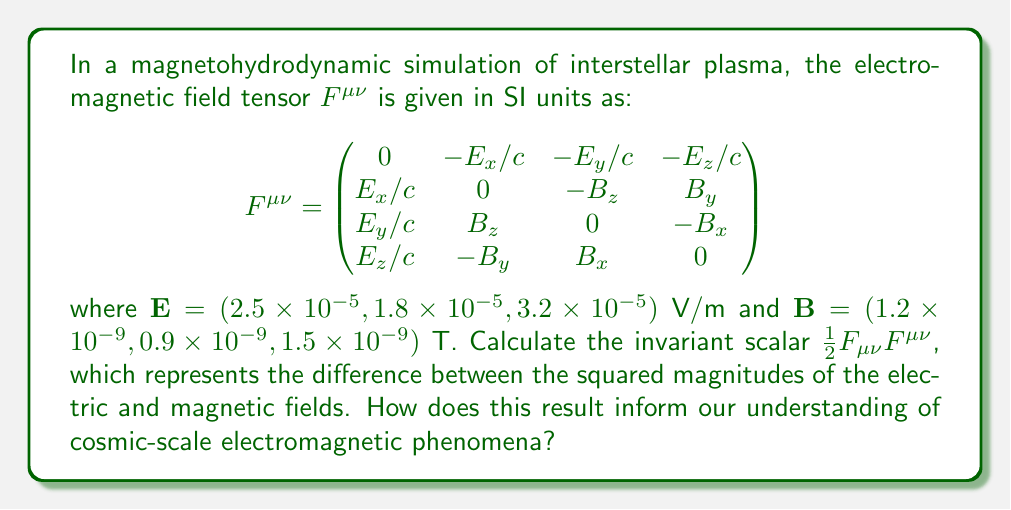Teach me how to tackle this problem. To solve this problem, we'll follow these steps:

1) First, we need to calculate $F_{\mu\nu}$. This is the covariant form of the tensor, obtained by lowering the indices of $F^{\mu\nu}$ using the Minkowski metric $\eta_{\mu\nu} = \text{diag}(-1, 1, 1, 1)$:

   $$F_{\mu\nu} = \begin{pmatrix}
   0 & E_x/c & E_y/c & E_z/c \\
   -E_x/c & 0 & -B_z & B_y \\
   -E_y/c & B_z & 0 & -B_x \\
   -E_z/c & -B_y & B_x & 0
   \end{pmatrix}$$

2) Now, we can calculate $\frac{1}{2}F_{\mu\nu}F^{\mu\nu}$. This contraction gives:

   $$\frac{1}{2}F_{\mu\nu}F^{\mu\nu} = \frac{1}{2}(-\frac{E_x^2}{c^2} - \frac{E_y^2}{c^2} - \frac{E_z^2}{c^2} + B_x^2 + B_y^2 + B_z^2 - \frac{E_x^2}{c^2} - \frac{E_y^2}{c^2} - \frac{E_z^2}{c^2} + B_x^2 + B_y^2 + B_z^2)$$

3) Simplifying:

   $$\frac{1}{2}F_{\mu\nu}F^{\mu\nu} = -\frac{E^2}{c^2} + B^2$$

   where $E^2 = E_x^2 + E_y^2 + E_z^2$ and $B^2 = B_x^2 + B_y^2 + B_z^2$.

4) Let's calculate $E^2$ and $B^2$:

   $E^2 = (2.5 \times 10^{-5})^2 + (1.8 \times 10^{-5})^2 + (3.2 \times 10^{-5})^2 = 2.018 \times 10^{-9}$ V²/m²

   $B^2 = (1.2 \times 10^{-9})^2 + (0.9 \times 10^{-9})^2 + (1.5 \times 10^{-9})^2 = 4.14 \times 10^{-18}$ T²

5) Now we can substitute these values:

   $$\frac{1}{2}F_{\mu\nu}F^{\mu\nu} = -\frac{2.018 \times 10^{-9}}{c^2} + 4.14 \times 10^{-18}$$

6) Using $c = 2.998 \times 10^8$ m/s:

   $$\frac{1}{2}F_{\mu\nu}F^{\mu\nu} = -2.24 \times 10^{-26} + 4.14 \times 10^{-18} \approx 4.14 \times 10^{-18}$$ T²

This result informs our understanding of cosmic-scale electromagnetic phenomena by showing that in this interstellar plasma, the magnetic energy density significantly dominates over the electric energy density. This is typical in highly conductive astrophysical plasmas, where electric fields are quickly shorted out. The prevalence of magnetic fields in interstellar space plays a crucial role in various astrophysical processes, including star formation, cosmic ray propagation, and galactic structure.
Answer: $4.14 \times 10^{-18}$ T² 